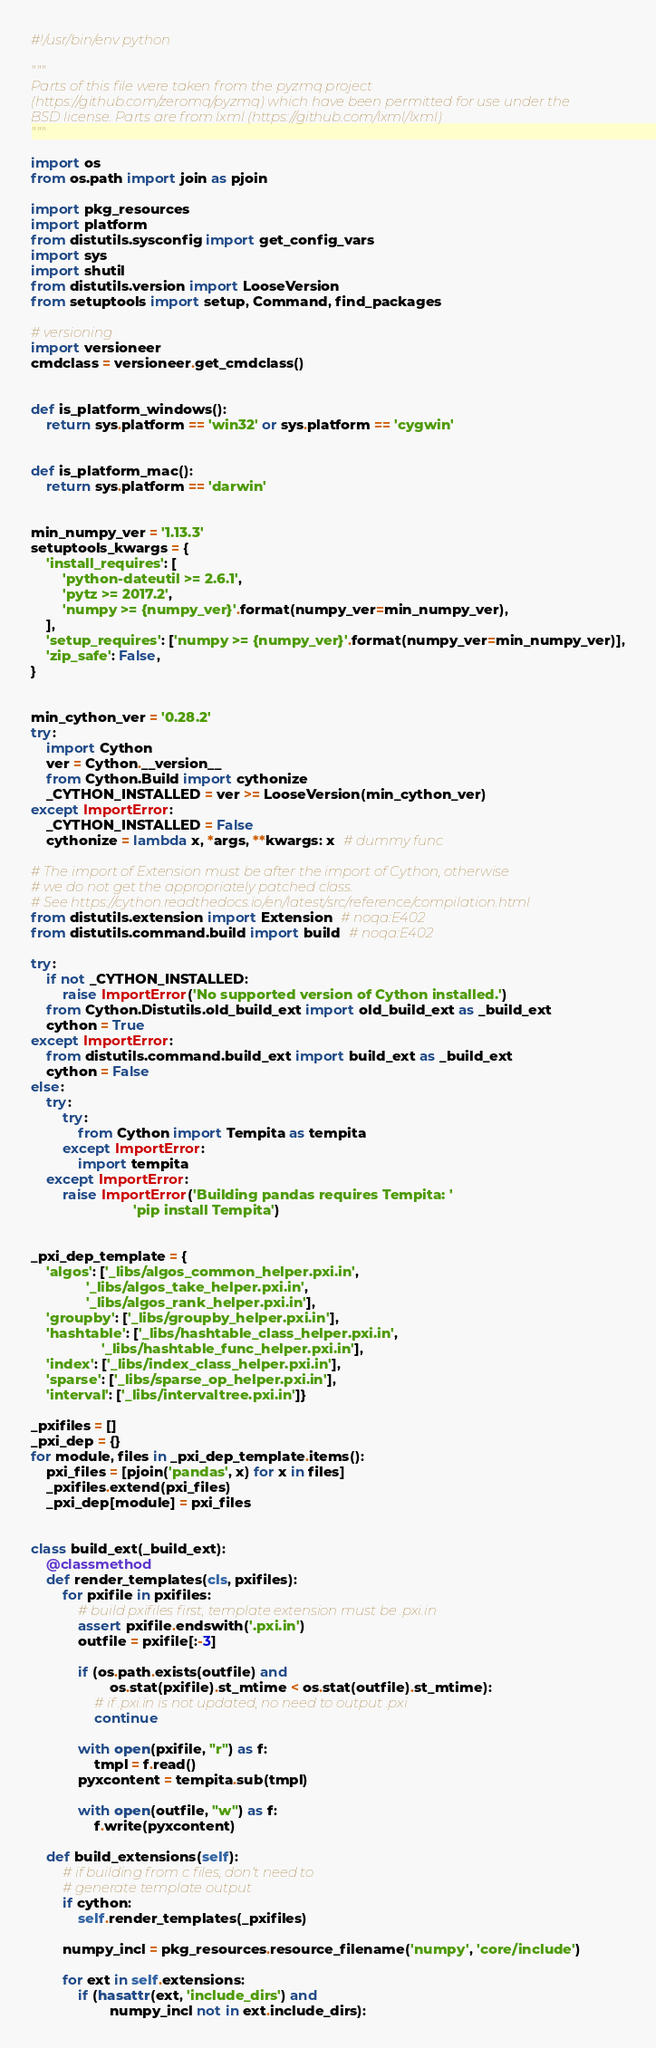Convert code to text. <code><loc_0><loc_0><loc_500><loc_500><_Python_>#!/usr/bin/env python

"""
Parts of this file were taken from the pyzmq project
(https://github.com/zeromq/pyzmq) which have been permitted for use under the
BSD license. Parts are from lxml (https://github.com/lxml/lxml)
"""

import os
from os.path import join as pjoin

import pkg_resources
import platform
from distutils.sysconfig import get_config_vars
import sys
import shutil
from distutils.version import LooseVersion
from setuptools import setup, Command, find_packages

# versioning
import versioneer
cmdclass = versioneer.get_cmdclass()


def is_platform_windows():
    return sys.platform == 'win32' or sys.platform == 'cygwin'


def is_platform_mac():
    return sys.platform == 'darwin'


min_numpy_ver = '1.13.3'
setuptools_kwargs = {
    'install_requires': [
        'python-dateutil >= 2.6.1',
        'pytz >= 2017.2',
        'numpy >= {numpy_ver}'.format(numpy_ver=min_numpy_ver),
    ],
    'setup_requires': ['numpy >= {numpy_ver}'.format(numpy_ver=min_numpy_ver)],
    'zip_safe': False,
}


min_cython_ver = '0.28.2'
try:
    import Cython
    ver = Cython.__version__
    from Cython.Build import cythonize
    _CYTHON_INSTALLED = ver >= LooseVersion(min_cython_ver)
except ImportError:
    _CYTHON_INSTALLED = False
    cythonize = lambda x, *args, **kwargs: x  # dummy func

# The import of Extension must be after the import of Cython, otherwise
# we do not get the appropriately patched class.
# See https://cython.readthedocs.io/en/latest/src/reference/compilation.html
from distutils.extension import Extension  # noqa:E402
from distutils.command.build import build  # noqa:E402

try:
    if not _CYTHON_INSTALLED:
        raise ImportError('No supported version of Cython installed.')
    from Cython.Distutils.old_build_ext import old_build_ext as _build_ext
    cython = True
except ImportError:
    from distutils.command.build_ext import build_ext as _build_ext
    cython = False
else:
    try:
        try:
            from Cython import Tempita as tempita
        except ImportError:
            import tempita
    except ImportError:
        raise ImportError('Building pandas requires Tempita: '
                          'pip install Tempita')


_pxi_dep_template = {
    'algos': ['_libs/algos_common_helper.pxi.in',
              '_libs/algos_take_helper.pxi.in',
              '_libs/algos_rank_helper.pxi.in'],
    'groupby': ['_libs/groupby_helper.pxi.in'],
    'hashtable': ['_libs/hashtable_class_helper.pxi.in',
                  '_libs/hashtable_func_helper.pxi.in'],
    'index': ['_libs/index_class_helper.pxi.in'],
    'sparse': ['_libs/sparse_op_helper.pxi.in'],
    'interval': ['_libs/intervaltree.pxi.in']}

_pxifiles = []
_pxi_dep = {}
for module, files in _pxi_dep_template.items():
    pxi_files = [pjoin('pandas', x) for x in files]
    _pxifiles.extend(pxi_files)
    _pxi_dep[module] = pxi_files


class build_ext(_build_ext):
    @classmethod
    def render_templates(cls, pxifiles):
        for pxifile in pxifiles:
            # build pxifiles first, template extension must be .pxi.in
            assert pxifile.endswith('.pxi.in')
            outfile = pxifile[:-3]

            if (os.path.exists(outfile) and
                    os.stat(pxifile).st_mtime < os.stat(outfile).st_mtime):
                # if .pxi.in is not updated, no need to output .pxi
                continue

            with open(pxifile, "r") as f:
                tmpl = f.read()
            pyxcontent = tempita.sub(tmpl)

            with open(outfile, "w") as f:
                f.write(pyxcontent)

    def build_extensions(self):
        # if building from c files, don't need to
        # generate template output
        if cython:
            self.render_templates(_pxifiles)

        numpy_incl = pkg_resources.resource_filename('numpy', 'core/include')

        for ext in self.extensions:
            if (hasattr(ext, 'include_dirs') and
                    numpy_incl not in ext.include_dirs):</code> 